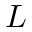<formula> <loc_0><loc_0><loc_500><loc_500>L</formula> 